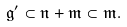<formula> <loc_0><loc_0><loc_500><loc_500>\mathfrak { g } ^ { \prime } \subset \mathfrak { n } + \mathfrak { m } \subset \mathfrak { m } .</formula> 